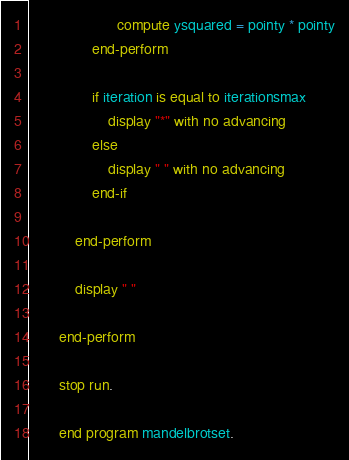Convert code to text. <code><loc_0><loc_0><loc_500><loc_500><_COBOL_>                     compute ysquared = pointy * pointy
               end-perform
       
               if iteration is equal to iterationsmax
                   display "*" with no advancing
               else
                   display " " with no advancing
               end-if
       
           end-perform
       
           display " "
       
       end-perform
       
       stop run.
       
       end program mandelbrotset.</code> 